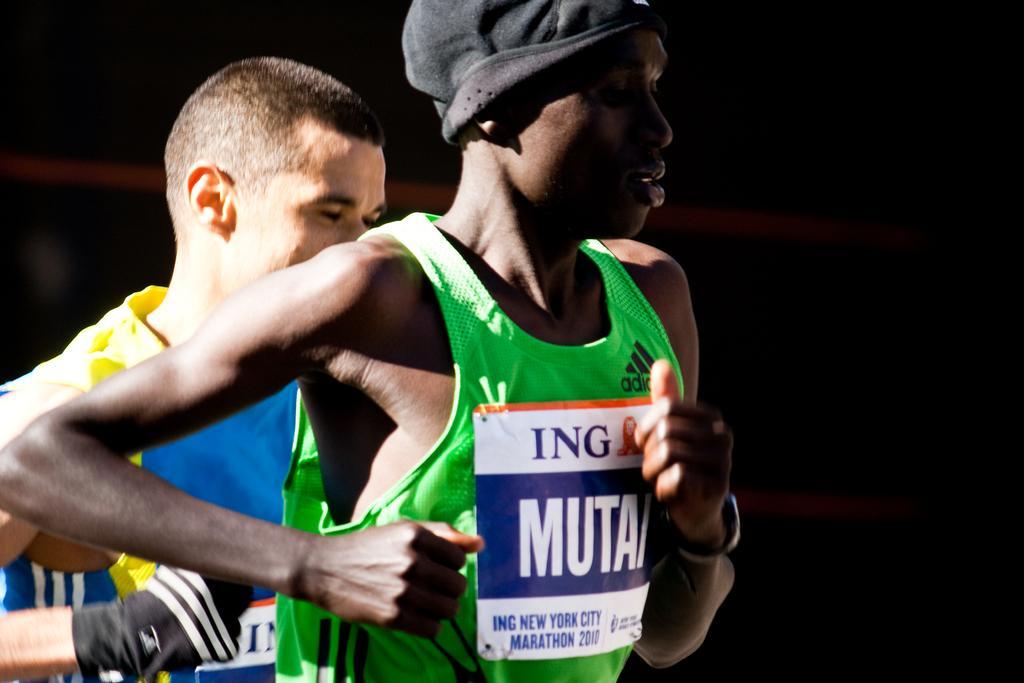Could you give a brief overview of what you see in this image? In this image there are two people. The background is dark. 